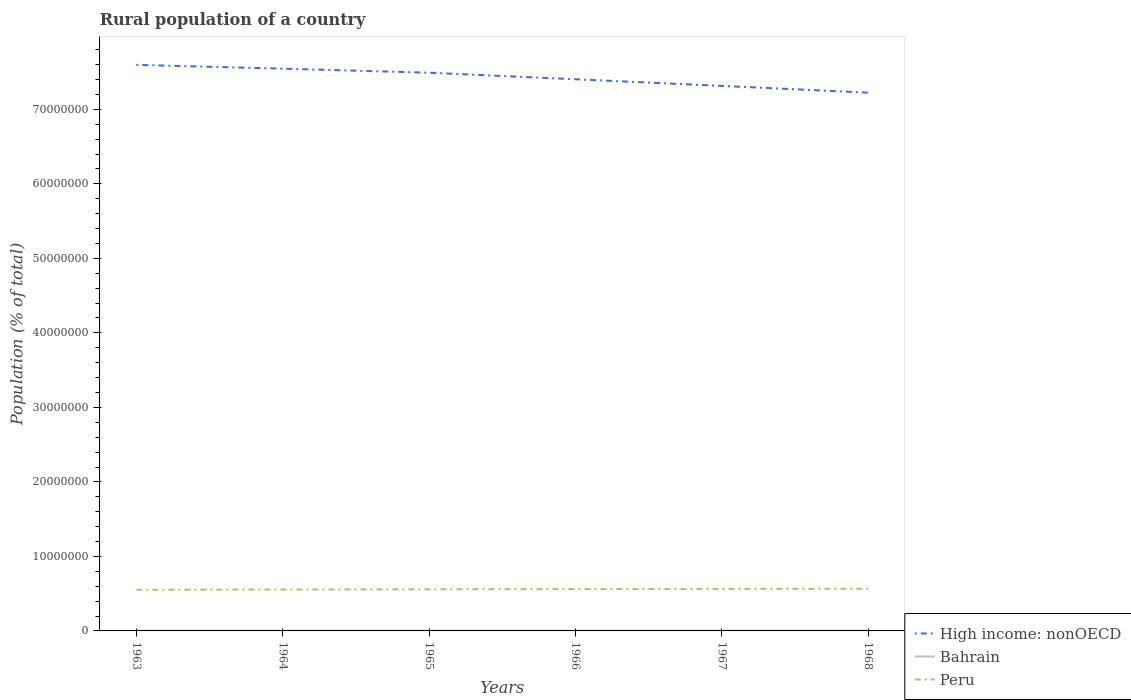How many different coloured lines are there?
Ensure brevity in your answer.  3. Is the number of lines equal to the number of legend labels?
Offer a very short reply. Yes. Across all years, what is the maximum rural population in Peru?
Keep it short and to the point. 5.52e+06. In which year was the rural population in High income: nonOECD maximum?
Your answer should be compact. 1968. What is the total rural population in Peru in the graph?
Make the answer very short. -1.17e+05. What is the difference between the highest and the second highest rural population in Peru?
Your response must be concise. 1.36e+05. What is the difference between the highest and the lowest rural population in Bahrain?
Your answer should be compact. 4. Is the rural population in High income: nonOECD strictly greater than the rural population in Bahrain over the years?
Provide a succinct answer. No. How many lines are there?
Provide a short and direct response. 3. How many years are there in the graph?
Keep it short and to the point. 6. What is the difference between two consecutive major ticks on the Y-axis?
Provide a succinct answer. 1.00e+07. Are the values on the major ticks of Y-axis written in scientific E-notation?
Ensure brevity in your answer.  No. Does the graph contain any zero values?
Provide a short and direct response. No. Does the graph contain grids?
Make the answer very short. No. How many legend labels are there?
Your response must be concise. 3. How are the legend labels stacked?
Give a very brief answer. Vertical. What is the title of the graph?
Your answer should be compact. Rural population of a country. What is the label or title of the Y-axis?
Your answer should be very brief. Population (% of total). What is the Population (% of total) in High income: nonOECD in 1963?
Ensure brevity in your answer.  7.60e+07. What is the Population (% of total) of Bahrain in 1963?
Offer a very short reply. 3.14e+04. What is the Population (% of total) in Peru in 1963?
Your answer should be compact. 5.52e+06. What is the Population (% of total) of High income: nonOECD in 1964?
Your answer should be compact. 7.55e+07. What is the Population (% of total) in Bahrain in 1964?
Give a very brief answer. 3.22e+04. What is the Population (% of total) in Peru in 1964?
Your response must be concise. 5.56e+06. What is the Population (% of total) of High income: nonOECD in 1965?
Your response must be concise. 7.49e+07. What is the Population (% of total) of Bahrain in 1965?
Your answer should be compact. 3.28e+04. What is the Population (% of total) of Peru in 1965?
Give a very brief answer. 5.59e+06. What is the Population (% of total) in High income: nonOECD in 1966?
Provide a short and direct response. 7.40e+07. What is the Population (% of total) of Bahrain in 1966?
Provide a succinct answer. 3.31e+04. What is the Population (% of total) of Peru in 1966?
Your response must be concise. 5.61e+06. What is the Population (% of total) of High income: nonOECD in 1967?
Offer a terse response. 7.32e+07. What is the Population (% of total) of Bahrain in 1967?
Give a very brief answer. 3.33e+04. What is the Population (% of total) in Peru in 1967?
Give a very brief answer. 5.64e+06. What is the Population (% of total) in High income: nonOECD in 1968?
Provide a succinct answer. 7.22e+07. What is the Population (% of total) of Bahrain in 1968?
Provide a succinct answer. 3.36e+04. What is the Population (% of total) of Peru in 1968?
Give a very brief answer. 5.66e+06. Across all years, what is the maximum Population (% of total) of High income: nonOECD?
Your answer should be compact. 7.60e+07. Across all years, what is the maximum Population (% of total) of Bahrain?
Your answer should be very brief. 3.36e+04. Across all years, what is the maximum Population (% of total) in Peru?
Ensure brevity in your answer.  5.66e+06. Across all years, what is the minimum Population (% of total) of High income: nonOECD?
Your answer should be very brief. 7.22e+07. Across all years, what is the minimum Population (% of total) of Bahrain?
Provide a succinct answer. 3.14e+04. Across all years, what is the minimum Population (% of total) of Peru?
Offer a very short reply. 5.52e+06. What is the total Population (% of total) of High income: nonOECD in the graph?
Make the answer very short. 4.46e+08. What is the total Population (% of total) of Bahrain in the graph?
Your response must be concise. 1.96e+05. What is the total Population (% of total) of Peru in the graph?
Keep it short and to the point. 3.36e+07. What is the difference between the Population (% of total) of High income: nonOECD in 1963 and that in 1964?
Give a very brief answer. 5.11e+05. What is the difference between the Population (% of total) in Bahrain in 1963 and that in 1964?
Give a very brief answer. -802. What is the difference between the Population (% of total) of Peru in 1963 and that in 1964?
Keep it short and to the point. -3.46e+04. What is the difference between the Population (% of total) in High income: nonOECD in 1963 and that in 1965?
Provide a short and direct response. 1.05e+06. What is the difference between the Population (% of total) in Bahrain in 1963 and that in 1965?
Offer a terse response. -1400. What is the difference between the Population (% of total) of Peru in 1963 and that in 1965?
Give a very brief answer. -6.59e+04. What is the difference between the Population (% of total) in High income: nonOECD in 1963 and that in 1966?
Provide a short and direct response. 1.93e+06. What is the difference between the Population (% of total) of Bahrain in 1963 and that in 1966?
Ensure brevity in your answer.  -1675. What is the difference between the Population (% of total) in Peru in 1963 and that in 1966?
Provide a short and direct response. -9.33e+04. What is the difference between the Population (% of total) in High income: nonOECD in 1963 and that in 1967?
Your response must be concise. 2.82e+06. What is the difference between the Population (% of total) of Bahrain in 1963 and that in 1967?
Provide a succinct answer. -1931. What is the difference between the Population (% of total) of Peru in 1963 and that in 1967?
Offer a terse response. -1.17e+05. What is the difference between the Population (% of total) in High income: nonOECD in 1963 and that in 1968?
Provide a short and direct response. 3.73e+06. What is the difference between the Population (% of total) of Bahrain in 1963 and that in 1968?
Make the answer very short. -2223. What is the difference between the Population (% of total) in Peru in 1963 and that in 1968?
Offer a terse response. -1.36e+05. What is the difference between the Population (% of total) in High income: nonOECD in 1964 and that in 1965?
Provide a short and direct response. 5.43e+05. What is the difference between the Population (% of total) of Bahrain in 1964 and that in 1965?
Make the answer very short. -598. What is the difference between the Population (% of total) of Peru in 1964 and that in 1965?
Offer a very short reply. -3.13e+04. What is the difference between the Population (% of total) of High income: nonOECD in 1964 and that in 1966?
Offer a very short reply. 1.42e+06. What is the difference between the Population (% of total) in Bahrain in 1964 and that in 1966?
Keep it short and to the point. -873. What is the difference between the Population (% of total) of Peru in 1964 and that in 1966?
Ensure brevity in your answer.  -5.88e+04. What is the difference between the Population (% of total) of High income: nonOECD in 1964 and that in 1967?
Give a very brief answer. 2.31e+06. What is the difference between the Population (% of total) in Bahrain in 1964 and that in 1967?
Provide a short and direct response. -1129. What is the difference between the Population (% of total) in Peru in 1964 and that in 1967?
Offer a terse response. -8.23e+04. What is the difference between the Population (% of total) in High income: nonOECD in 1964 and that in 1968?
Your response must be concise. 3.22e+06. What is the difference between the Population (% of total) of Bahrain in 1964 and that in 1968?
Keep it short and to the point. -1421. What is the difference between the Population (% of total) in Peru in 1964 and that in 1968?
Make the answer very short. -1.01e+05. What is the difference between the Population (% of total) in High income: nonOECD in 1965 and that in 1966?
Offer a terse response. 8.77e+05. What is the difference between the Population (% of total) of Bahrain in 1965 and that in 1966?
Provide a short and direct response. -275. What is the difference between the Population (% of total) of Peru in 1965 and that in 1966?
Offer a terse response. -2.74e+04. What is the difference between the Population (% of total) in High income: nonOECD in 1965 and that in 1967?
Your answer should be compact. 1.77e+06. What is the difference between the Population (% of total) in Bahrain in 1965 and that in 1967?
Your answer should be very brief. -531. What is the difference between the Population (% of total) of Peru in 1965 and that in 1967?
Provide a short and direct response. -5.10e+04. What is the difference between the Population (% of total) of High income: nonOECD in 1965 and that in 1968?
Your response must be concise. 2.68e+06. What is the difference between the Population (% of total) in Bahrain in 1965 and that in 1968?
Your response must be concise. -823. What is the difference between the Population (% of total) of Peru in 1965 and that in 1968?
Your answer should be very brief. -7.00e+04. What is the difference between the Population (% of total) in High income: nonOECD in 1966 and that in 1967?
Ensure brevity in your answer.  8.91e+05. What is the difference between the Population (% of total) of Bahrain in 1966 and that in 1967?
Your answer should be compact. -256. What is the difference between the Population (% of total) in Peru in 1966 and that in 1967?
Your response must be concise. -2.35e+04. What is the difference between the Population (% of total) of High income: nonOECD in 1966 and that in 1968?
Give a very brief answer. 1.80e+06. What is the difference between the Population (% of total) of Bahrain in 1966 and that in 1968?
Offer a very short reply. -548. What is the difference between the Population (% of total) of Peru in 1966 and that in 1968?
Provide a succinct answer. -4.26e+04. What is the difference between the Population (% of total) in High income: nonOECD in 1967 and that in 1968?
Offer a terse response. 9.10e+05. What is the difference between the Population (% of total) of Bahrain in 1967 and that in 1968?
Provide a short and direct response. -292. What is the difference between the Population (% of total) of Peru in 1967 and that in 1968?
Make the answer very short. -1.91e+04. What is the difference between the Population (% of total) of High income: nonOECD in 1963 and the Population (% of total) of Bahrain in 1964?
Offer a very short reply. 7.59e+07. What is the difference between the Population (% of total) in High income: nonOECD in 1963 and the Population (% of total) in Peru in 1964?
Offer a terse response. 7.04e+07. What is the difference between the Population (% of total) of Bahrain in 1963 and the Population (% of total) of Peru in 1964?
Offer a terse response. -5.52e+06. What is the difference between the Population (% of total) of High income: nonOECD in 1963 and the Population (% of total) of Bahrain in 1965?
Your response must be concise. 7.59e+07. What is the difference between the Population (% of total) in High income: nonOECD in 1963 and the Population (% of total) in Peru in 1965?
Keep it short and to the point. 7.04e+07. What is the difference between the Population (% of total) of Bahrain in 1963 and the Population (% of total) of Peru in 1965?
Your answer should be very brief. -5.56e+06. What is the difference between the Population (% of total) in High income: nonOECD in 1963 and the Population (% of total) in Bahrain in 1966?
Offer a terse response. 7.59e+07. What is the difference between the Population (% of total) in High income: nonOECD in 1963 and the Population (% of total) in Peru in 1966?
Keep it short and to the point. 7.04e+07. What is the difference between the Population (% of total) of Bahrain in 1963 and the Population (% of total) of Peru in 1966?
Your answer should be compact. -5.58e+06. What is the difference between the Population (% of total) in High income: nonOECD in 1963 and the Population (% of total) in Bahrain in 1967?
Give a very brief answer. 7.59e+07. What is the difference between the Population (% of total) of High income: nonOECD in 1963 and the Population (% of total) of Peru in 1967?
Offer a terse response. 7.03e+07. What is the difference between the Population (% of total) in Bahrain in 1963 and the Population (% of total) in Peru in 1967?
Offer a terse response. -5.61e+06. What is the difference between the Population (% of total) of High income: nonOECD in 1963 and the Population (% of total) of Bahrain in 1968?
Make the answer very short. 7.59e+07. What is the difference between the Population (% of total) in High income: nonOECD in 1963 and the Population (% of total) in Peru in 1968?
Offer a very short reply. 7.03e+07. What is the difference between the Population (% of total) in Bahrain in 1963 and the Population (% of total) in Peru in 1968?
Offer a terse response. -5.63e+06. What is the difference between the Population (% of total) in High income: nonOECD in 1964 and the Population (% of total) in Bahrain in 1965?
Keep it short and to the point. 7.54e+07. What is the difference between the Population (% of total) of High income: nonOECD in 1964 and the Population (% of total) of Peru in 1965?
Your answer should be very brief. 6.99e+07. What is the difference between the Population (% of total) of Bahrain in 1964 and the Population (% of total) of Peru in 1965?
Provide a succinct answer. -5.55e+06. What is the difference between the Population (% of total) in High income: nonOECD in 1964 and the Population (% of total) in Bahrain in 1966?
Provide a short and direct response. 7.54e+07. What is the difference between the Population (% of total) of High income: nonOECD in 1964 and the Population (% of total) of Peru in 1966?
Ensure brevity in your answer.  6.98e+07. What is the difference between the Population (% of total) of Bahrain in 1964 and the Population (% of total) of Peru in 1966?
Your answer should be very brief. -5.58e+06. What is the difference between the Population (% of total) of High income: nonOECD in 1964 and the Population (% of total) of Bahrain in 1967?
Your response must be concise. 7.54e+07. What is the difference between the Population (% of total) in High income: nonOECD in 1964 and the Population (% of total) in Peru in 1967?
Give a very brief answer. 6.98e+07. What is the difference between the Population (% of total) in Bahrain in 1964 and the Population (% of total) in Peru in 1967?
Provide a short and direct response. -5.61e+06. What is the difference between the Population (% of total) in High income: nonOECD in 1964 and the Population (% of total) in Bahrain in 1968?
Your answer should be very brief. 7.54e+07. What is the difference between the Population (% of total) of High income: nonOECD in 1964 and the Population (% of total) of Peru in 1968?
Make the answer very short. 6.98e+07. What is the difference between the Population (% of total) of Bahrain in 1964 and the Population (% of total) of Peru in 1968?
Your answer should be very brief. -5.62e+06. What is the difference between the Population (% of total) of High income: nonOECD in 1965 and the Population (% of total) of Bahrain in 1966?
Ensure brevity in your answer.  7.49e+07. What is the difference between the Population (% of total) of High income: nonOECD in 1965 and the Population (% of total) of Peru in 1966?
Provide a succinct answer. 6.93e+07. What is the difference between the Population (% of total) of Bahrain in 1965 and the Population (% of total) of Peru in 1966?
Your answer should be very brief. -5.58e+06. What is the difference between the Population (% of total) of High income: nonOECD in 1965 and the Population (% of total) of Bahrain in 1967?
Provide a short and direct response. 7.49e+07. What is the difference between the Population (% of total) of High income: nonOECD in 1965 and the Population (% of total) of Peru in 1967?
Give a very brief answer. 6.93e+07. What is the difference between the Population (% of total) in Bahrain in 1965 and the Population (% of total) in Peru in 1967?
Your answer should be compact. -5.61e+06. What is the difference between the Population (% of total) of High income: nonOECD in 1965 and the Population (% of total) of Bahrain in 1968?
Ensure brevity in your answer.  7.49e+07. What is the difference between the Population (% of total) in High income: nonOECD in 1965 and the Population (% of total) in Peru in 1968?
Make the answer very short. 6.93e+07. What is the difference between the Population (% of total) of Bahrain in 1965 and the Population (% of total) of Peru in 1968?
Keep it short and to the point. -5.62e+06. What is the difference between the Population (% of total) in High income: nonOECD in 1966 and the Population (% of total) in Bahrain in 1967?
Provide a succinct answer. 7.40e+07. What is the difference between the Population (% of total) of High income: nonOECD in 1966 and the Population (% of total) of Peru in 1967?
Provide a short and direct response. 6.84e+07. What is the difference between the Population (% of total) of Bahrain in 1966 and the Population (% of total) of Peru in 1967?
Offer a very short reply. -5.60e+06. What is the difference between the Population (% of total) of High income: nonOECD in 1966 and the Population (% of total) of Bahrain in 1968?
Ensure brevity in your answer.  7.40e+07. What is the difference between the Population (% of total) of High income: nonOECD in 1966 and the Population (% of total) of Peru in 1968?
Your answer should be compact. 6.84e+07. What is the difference between the Population (% of total) of Bahrain in 1966 and the Population (% of total) of Peru in 1968?
Ensure brevity in your answer.  -5.62e+06. What is the difference between the Population (% of total) of High income: nonOECD in 1967 and the Population (% of total) of Bahrain in 1968?
Your response must be concise. 7.31e+07. What is the difference between the Population (% of total) of High income: nonOECD in 1967 and the Population (% of total) of Peru in 1968?
Provide a short and direct response. 6.75e+07. What is the difference between the Population (% of total) in Bahrain in 1967 and the Population (% of total) in Peru in 1968?
Ensure brevity in your answer.  -5.62e+06. What is the average Population (% of total) in High income: nonOECD per year?
Your response must be concise. 7.43e+07. What is the average Population (% of total) in Bahrain per year?
Ensure brevity in your answer.  3.27e+04. What is the average Population (% of total) in Peru per year?
Offer a terse response. 5.60e+06. In the year 1963, what is the difference between the Population (% of total) of High income: nonOECD and Population (% of total) of Bahrain?
Provide a short and direct response. 7.59e+07. In the year 1963, what is the difference between the Population (% of total) in High income: nonOECD and Population (% of total) in Peru?
Ensure brevity in your answer.  7.05e+07. In the year 1963, what is the difference between the Population (% of total) of Bahrain and Population (% of total) of Peru?
Provide a succinct answer. -5.49e+06. In the year 1964, what is the difference between the Population (% of total) of High income: nonOECD and Population (% of total) of Bahrain?
Your answer should be compact. 7.54e+07. In the year 1964, what is the difference between the Population (% of total) of High income: nonOECD and Population (% of total) of Peru?
Offer a very short reply. 6.99e+07. In the year 1964, what is the difference between the Population (% of total) in Bahrain and Population (% of total) in Peru?
Your answer should be very brief. -5.52e+06. In the year 1965, what is the difference between the Population (% of total) in High income: nonOECD and Population (% of total) in Bahrain?
Offer a very short reply. 7.49e+07. In the year 1965, what is the difference between the Population (% of total) of High income: nonOECD and Population (% of total) of Peru?
Offer a terse response. 6.93e+07. In the year 1965, what is the difference between the Population (% of total) of Bahrain and Population (% of total) of Peru?
Provide a succinct answer. -5.55e+06. In the year 1966, what is the difference between the Population (% of total) in High income: nonOECD and Population (% of total) in Bahrain?
Provide a succinct answer. 7.40e+07. In the year 1966, what is the difference between the Population (% of total) of High income: nonOECD and Population (% of total) of Peru?
Offer a very short reply. 6.84e+07. In the year 1966, what is the difference between the Population (% of total) in Bahrain and Population (% of total) in Peru?
Provide a succinct answer. -5.58e+06. In the year 1967, what is the difference between the Population (% of total) in High income: nonOECD and Population (% of total) in Bahrain?
Keep it short and to the point. 7.31e+07. In the year 1967, what is the difference between the Population (% of total) of High income: nonOECD and Population (% of total) of Peru?
Keep it short and to the point. 6.75e+07. In the year 1967, what is the difference between the Population (% of total) in Bahrain and Population (% of total) in Peru?
Make the answer very short. -5.60e+06. In the year 1968, what is the difference between the Population (% of total) in High income: nonOECD and Population (% of total) in Bahrain?
Offer a very short reply. 7.22e+07. In the year 1968, what is the difference between the Population (% of total) of High income: nonOECD and Population (% of total) of Peru?
Ensure brevity in your answer.  6.66e+07. In the year 1968, what is the difference between the Population (% of total) in Bahrain and Population (% of total) in Peru?
Offer a very short reply. -5.62e+06. What is the ratio of the Population (% of total) of High income: nonOECD in 1963 to that in 1964?
Your response must be concise. 1.01. What is the ratio of the Population (% of total) of Bahrain in 1963 to that in 1964?
Your answer should be very brief. 0.98. What is the ratio of the Population (% of total) in High income: nonOECD in 1963 to that in 1965?
Keep it short and to the point. 1.01. What is the ratio of the Population (% of total) of Bahrain in 1963 to that in 1965?
Your response must be concise. 0.96. What is the ratio of the Population (% of total) in Peru in 1963 to that in 1965?
Your answer should be very brief. 0.99. What is the ratio of the Population (% of total) in High income: nonOECD in 1963 to that in 1966?
Provide a succinct answer. 1.03. What is the ratio of the Population (% of total) of Bahrain in 1963 to that in 1966?
Ensure brevity in your answer.  0.95. What is the ratio of the Population (% of total) of Peru in 1963 to that in 1966?
Your response must be concise. 0.98. What is the ratio of the Population (% of total) of High income: nonOECD in 1963 to that in 1967?
Make the answer very short. 1.04. What is the ratio of the Population (% of total) of Bahrain in 1963 to that in 1967?
Make the answer very short. 0.94. What is the ratio of the Population (% of total) in Peru in 1963 to that in 1967?
Provide a succinct answer. 0.98. What is the ratio of the Population (% of total) of High income: nonOECD in 1963 to that in 1968?
Make the answer very short. 1.05. What is the ratio of the Population (% of total) of Bahrain in 1963 to that in 1968?
Provide a short and direct response. 0.93. What is the ratio of the Population (% of total) of Bahrain in 1964 to that in 1965?
Provide a succinct answer. 0.98. What is the ratio of the Population (% of total) in Peru in 1964 to that in 1965?
Your answer should be compact. 0.99. What is the ratio of the Population (% of total) of High income: nonOECD in 1964 to that in 1966?
Offer a terse response. 1.02. What is the ratio of the Population (% of total) of Bahrain in 1964 to that in 1966?
Offer a very short reply. 0.97. What is the ratio of the Population (% of total) in Peru in 1964 to that in 1966?
Give a very brief answer. 0.99. What is the ratio of the Population (% of total) of High income: nonOECD in 1964 to that in 1967?
Give a very brief answer. 1.03. What is the ratio of the Population (% of total) in Bahrain in 1964 to that in 1967?
Your answer should be compact. 0.97. What is the ratio of the Population (% of total) in Peru in 1964 to that in 1967?
Offer a very short reply. 0.99. What is the ratio of the Population (% of total) in High income: nonOECD in 1964 to that in 1968?
Ensure brevity in your answer.  1.04. What is the ratio of the Population (% of total) of Bahrain in 1964 to that in 1968?
Give a very brief answer. 0.96. What is the ratio of the Population (% of total) of Peru in 1964 to that in 1968?
Offer a very short reply. 0.98. What is the ratio of the Population (% of total) in High income: nonOECD in 1965 to that in 1966?
Offer a terse response. 1.01. What is the ratio of the Population (% of total) of High income: nonOECD in 1965 to that in 1967?
Give a very brief answer. 1.02. What is the ratio of the Population (% of total) of Bahrain in 1965 to that in 1967?
Your answer should be very brief. 0.98. What is the ratio of the Population (% of total) of High income: nonOECD in 1965 to that in 1968?
Offer a terse response. 1.04. What is the ratio of the Population (% of total) in Bahrain in 1965 to that in 1968?
Your response must be concise. 0.98. What is the ratio of the Population (% of total) in Peru in 1965 to that in 1968?
Give a very brief answer. 0.99. What is the ratio of the Population (% of total) of High income: nonOECD in 1966 to that in 1967?
Offer a terse response. 1.01. What is the ratio of the Population (% of total) in Bahrain in 1966 to that in 1967?
Your response must be concise. 0.99. What is the ratio of the Population (% of total) of High income: nonOECD in 1966 to that in 1968?
Your answer should be very brief. 1.02. What is the ratio of the Population (% of total) of Bahrain in 1966 to that in 1968?
Ensure brevity in your answer.  0.98. What is the ratio of the Population (% of total) of High income: nonOECD in 1967 to that in 1968?
Provide a succinct answer. 1.01. What is the difference between the highest and the second highest Population (% of total) of High income: nonOECD?
Give a very brief answer. 5.11e+05. What is the difference between the highest and the second highest Population (% of total) of Bahrain?
Keep it short and to the point. 292. What is the difference between the highest and the second highest Population (% of total) of Peru?
Make the answer very short. 1.91e+04. What is the difference between the highest and the lowest Population (% of total) of High income: nonOECD?
Your answer should be compact. 3.73e+06. What is the difference between the highest and the lowest Population (% of total) of Bahrain?
Provide a succinct answer. 2223. What is the difference between the highest and the lowest Population (% of total) in Peru?
Your response must be concise. 1.36e+05. 